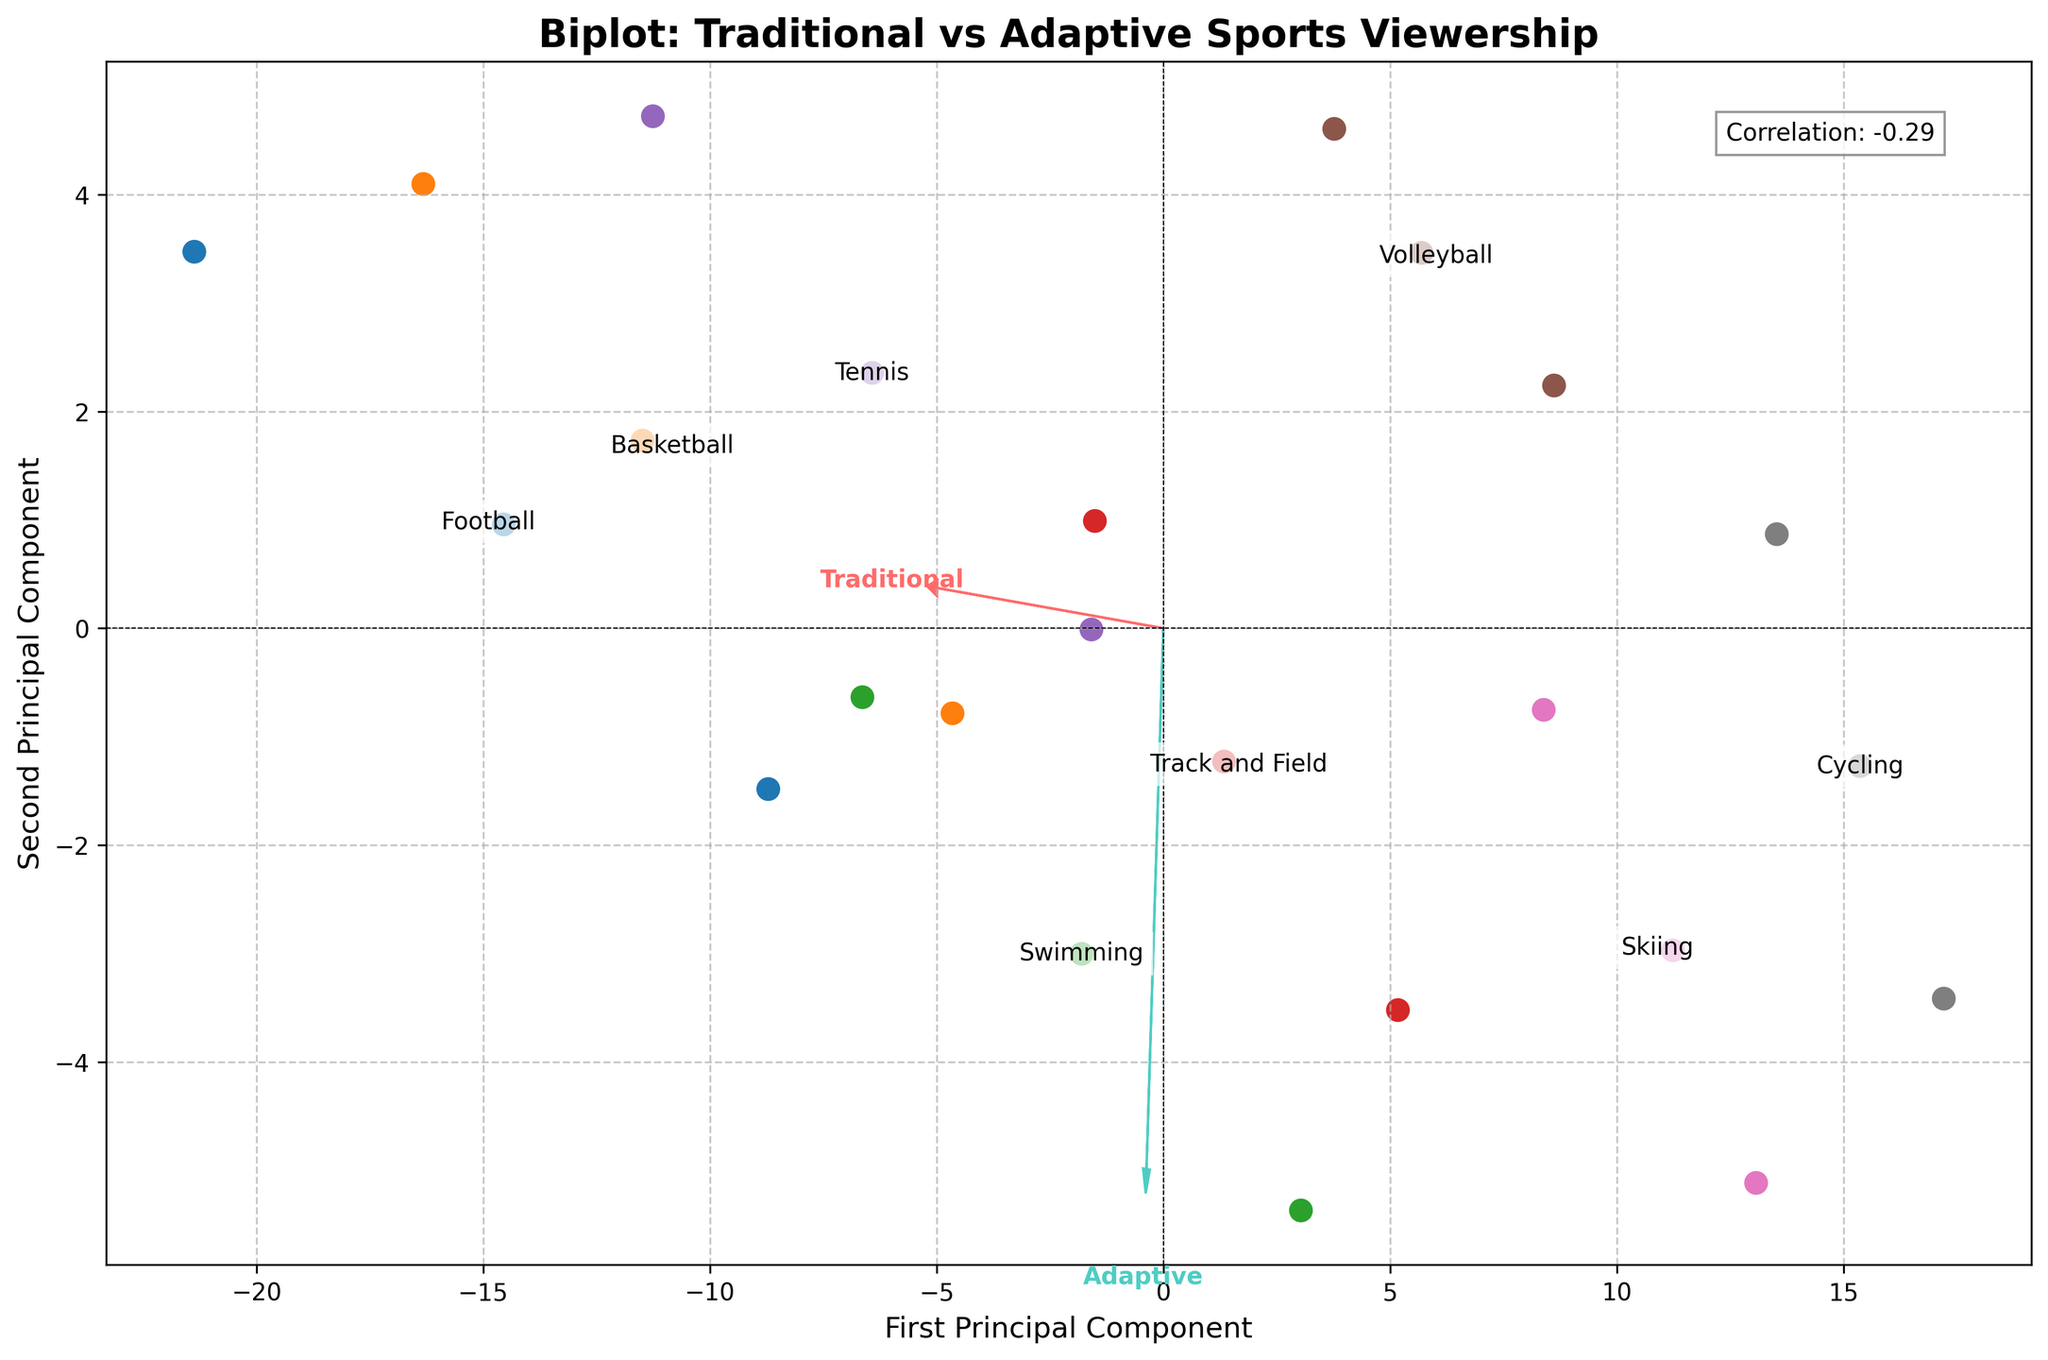What's the title of the figure? The title is typically shown at the top of the figure and it represents the main idea of the visualization, which in this case is a comparison between traditional and adaptive sports viewership across age groups.
Answer: Biplot: Traditional vs Adaptive Sports Viewership How many principal components are represented in the figure? Principal components are the axes onto which the data points are projected. The axes labels indicate the number of principal components shown.
Answer: Two Which sport has the highest viewership among the 18-34 age group for traditional sports? By examining the scattered points on the biplot, we can identify the sport with the highest position corresponding to the traditional 18-34 age group viewing data.
Answer: Football What is the color of the loading vector for adaptive sports? The loading vector is typically an arrow that shows the direction and magnitude of principal components. The color of the arrow for adaptive sports can be inferred from the figure's legend or visual representation.
Answer: Turquoise What does the correlation coefficient in the figure indicate? The correlation coefficient shown in the figure gives an idea of how strongly traditional and adaptive sports viewership data correlate, which can be interpreted directly from the text annotation.
Answer: 0.85 Which adaptive sport has the highest viewership in the 55+ age group? Considering the scattered points and labels, we look for the highest value in the adaptive sports section among the 55+ age group.
Answer: Swimming Compare the viewership difference for basketball between the 18-34 and 55+ age groups in traditional sports. From the data points for basketball in the figure, identify the positions corresponding to the 18-34 and 55+ age groups and calculate their difference.
Answer: 12 Which sport shows the smallest difference between traditional and adaptive sports viewership for 35-54 age group? To find this, compare the proximity of the data points for traditional and adaptive viewership within the 35-54 age group. The sport with the closest points represents the smallest difference.
Answer: Track and Field What does the direction of the first principal component (PC1) convey? The direction of the first principal component provides insight into the major variance in the dataset. The alignment and separation of the sport data points along this axis represent the variation in viewership between traditional and adaptive sports.
Answer: Maximizes variance in viewership Does the figure show a large disparity in the viewership trends between traditional and adaptive sports? By observing the scattering of data points and the loading vectors, one can visually assess how spread apart the traditional and adaptive sports viewership data are across different age groups, indicating disparity or similarity.
Answer: Yes 